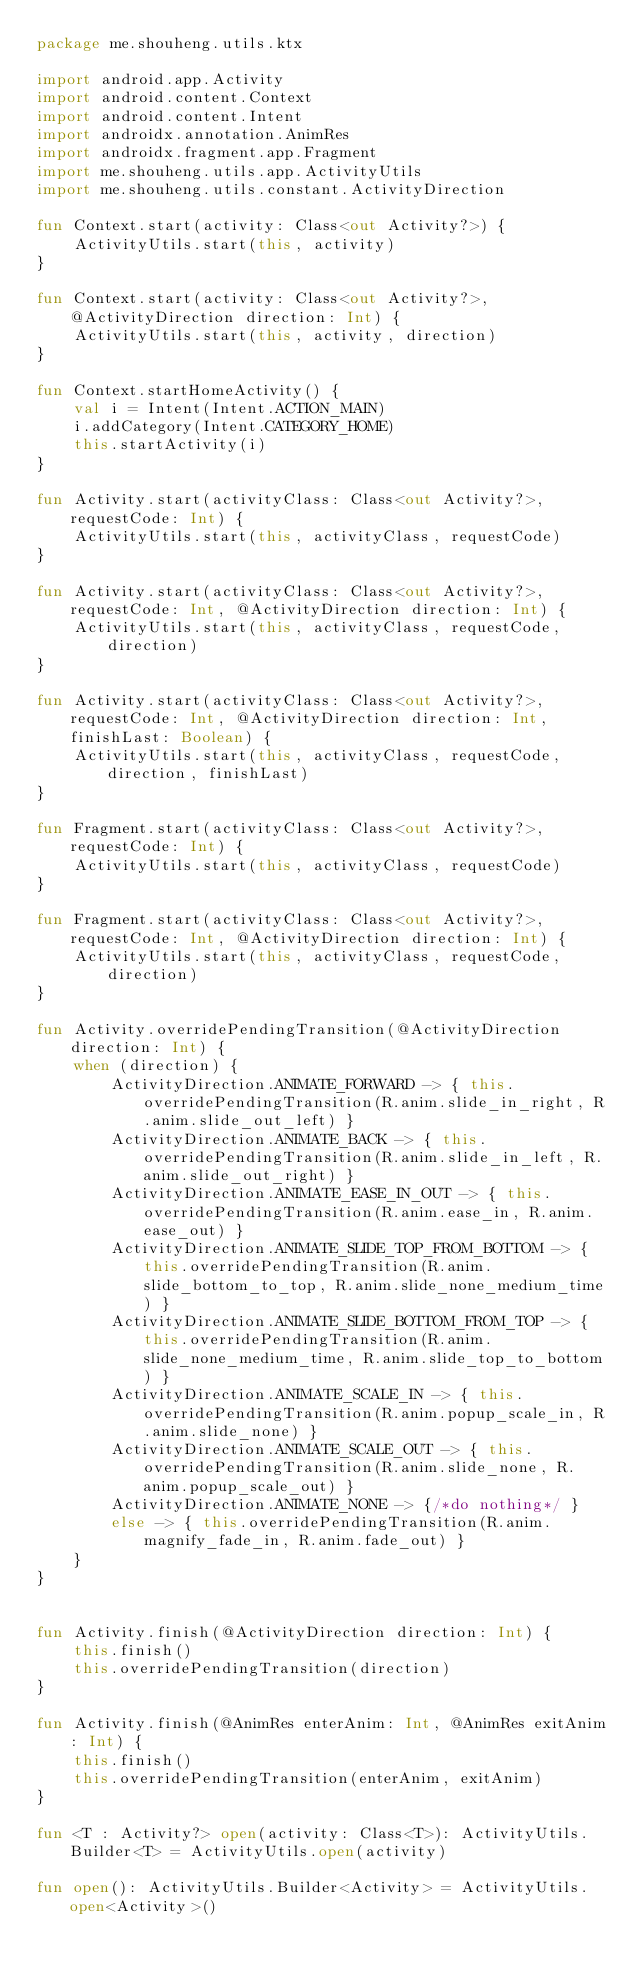Convert code to text. <code><loc_0><loc_0><loc_500><loc_500><_Kotlin_>package me.shouheng.utils.ktx

import android.app.Activity
import android.content.Context
import android.content.Intent
import androidx.annotation.AnimRes
import androidx.fragment.app.Fragment
import me.shouheng.utils.app.ActivityUtils
import me.shouheng.utils.constant.ActivityDirection

fun Context.start(activity: Class<out Activity?>) {
    ActivityUtils.start(this, activity)
}

fun Context.start(activity: Class<out Activity?>, @ActivityDirection direction: Int) {
    ActivityUtils.start(this, activity, direction)
}

fun Context.startHomeActivity() {
    val i = Intent(Intent.ACTION_MAIN)
    i.addCategory(Intent.CATEGORY_HOME)
    this.startActivity(i)
}

fun Activity.start(activityClass: Class<out Activity?>, requestCode: Int) {
    ActivityUtils.start(this, activityClass, requestCode)
}

fun Activity.start(activityClass: Class<out Activity?>, requestCode: Int, @ActivityDirection direction: Int) {
    ActivityUtils.start(this, activityClass, requestCode, direction)
}

fun Activity.start(activityClass: Class<out Activity?>, requestCode: Int, @ActivityDirection direction: Int, finishLast: Boolean) {
    ActivityUtils.start(this, activityClass, requestCode, direction, finishLast)
}

fun Fragment.start(activityClass: Class<out Activity?>, requestCode: Int) {
    ActivityUtils.start(this, activityClass, requestCode)
}

fun Fragment.start(activityClass: Class<out Activity?>, requestCode: Int, @ActivityDirection direction: Int) {
    ActivityUtils.start(this, activityClass, requestCode, direction)
}

fun Activity.overridePendingTransition(@ActivityDirection direction: Int) {
    when (direction) {
        ActivityDirection.ANIMATE_FORWARD -> { this.overridePendingTransition(R.anim.slide_in_right, R.anim.slide_out_left) }
        ActivityDirection.ANIMATE_BACK -> { this.overridePendingTransition(R.anim.slide_in_left, R.anim.slide_out_right) }
        ActivityDirection.ANIMATE_EASE_IN_OUT -> { this.overridePendingTransition(R.anim.ease_in, R.anim.ease_out) }
        ActivityDirection.ANIMATE_SLIDE_TOP_FROM_BOTTOM -> { this.overridePendingTransition(R.anim.slide_bottom_to_top, R.anim.slide_none_medium_time) }
        ActivityDirection.ANIMATE_SLIDE_BOTTOM_FROM_TOP -> { this.overridePendingTransition(R.anim.slide_none_medium_time, R.anim.slide_top_to_bottom) }
        ActivityDirection.ANIMATE_SCALE_IN -> { this.overridePendingTransition(R.anim.popup_scale_in, R.anim.slide_none) }
        ActivityDirection.ANIMATE_SCALE_OUT -> { this.overridePendingTransition(R.anim.slide_none, R.anim.popup_scale_out) }
        ActivityDirection.ANIMATE_NONE -> {/*do nothing*/ }
        else -> { this.overridePendingTransition(R.anim.magnify_fade_in, R.anim.fade_out) }
    }
}


fun Activity.finish(@ActivityDirection direction: Int) {
    this.finish()
    this.overridePendingTransition(direction)
}

fun Activity.finish(@AnimRes enterAnim: Int, @AnimRes exitAnim: Int) {
    this.finish()
    this.overridePendingTransition(enterAnim, exitAnim)
}

fun <T : Activity?> open(activity: Class<T>): ActivityUtils.Builder<T> = ActivityUtils.open(activity)

fun open(): ActivityUtils.Builder<Activity> = ActivityUtils.open<Activity>()
</code> 